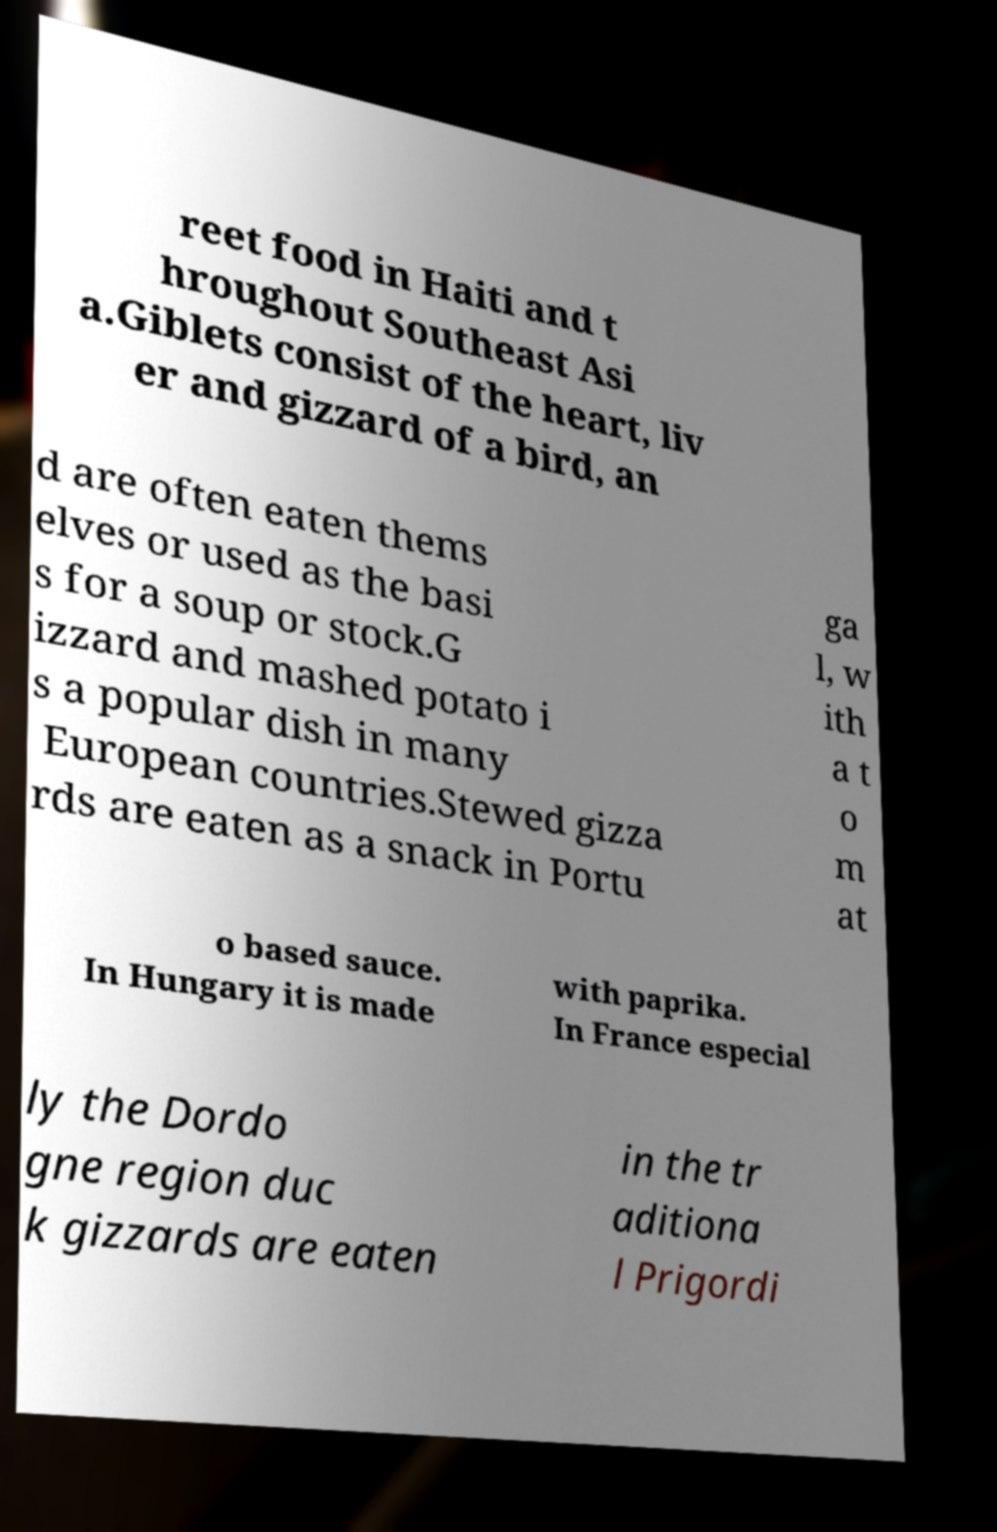For documentation purposes, I need the text within this image transcribed. Could you provide that? reet food in Haiti and t hroughout Southeast Asi a.Giblets consist of the heart, liv er and gizzard of a bird, an d are often eaten thems elves or used as the basi s for a soup or stock.G izzard and mashed potato i s a popular dish in many European countries.Stewed gizza rds are eaten as a snack in Portu ga l, w ith a t o m at o based sauce. In Hungary it is made with paprika. In France especial ly the Dordo gne region duc k gizzards are eaten in the tr aditiona l Prigordi 